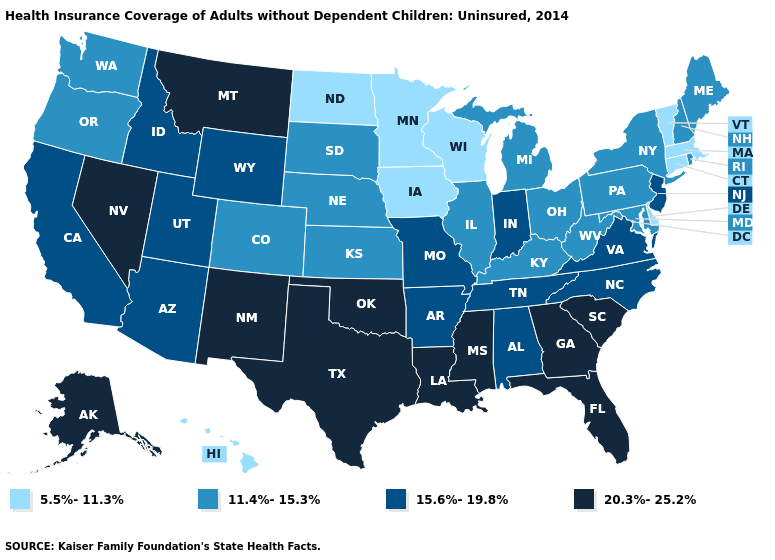Among the states that border Indiana , which have the lowest value?
Short answer required. Illinois, Kentucky, Michigan, Ohio. What is the value of Ohio?
Give a very brief answer. 11.4%-15.3%. Does Virginia have a lower value than Nebraska?
Quick response, please. No. What is the value of Idaho?
Write a very short answer. 15.6%-19.8%. Name the states that have a value in the range 11.4%-15.3%?
Write a very short answer. Colorado, Illinois, Kansas, Kentucky, Maine, Maryland, Michigan, Nebraska, New Hampshire, New York, Ohio, Oregon, Pennsylvania, Rhode Island, South Dakota, Washington, West Virginia. Which states have the lowest value in the West?
Be succinct. Hawaii. Name the states that have a value in the range 15.6%-19.8%?
Write a very short answer. Alabama, Arizona, Arkansas, California, Idaho, Indiana, Missouri, New Jersey, North Carolina, Tennessee, Utah, Virginia, Wyoming. What is the value of Nebraska?
Give a very brief answer. 11.4%-15.3%. What is the value of Tennessee?
Give a very brief answer. 15.6%-19.8%. Among the states that border Utah , does Colorado have the lowest value?
Quick response, please. Yes. What is the highest value in the MidWest ?
Keep it brief. 15.6%-19.8%. Among the states that border Wisconsin , which have the highest value?
Be succinct. Illinois, Michigan. What is the lowest value in the Northeast?
Quick response, please. 5.5%-11.3%. Does Oregon have a higher value than Delaware?
Write a very short answer. Yes. Name the states that have a value in the range 11.4%-15.3%?
Write a very short answer. Colorado, Illinois, Kansas, Kentucky, Maine, Maryland, Michigan, Nebraska, New Hampshire, New York, Ohio, Oregon, Pennsylvania, Rhode Island, South Dakota, Washington, West Virginia. 